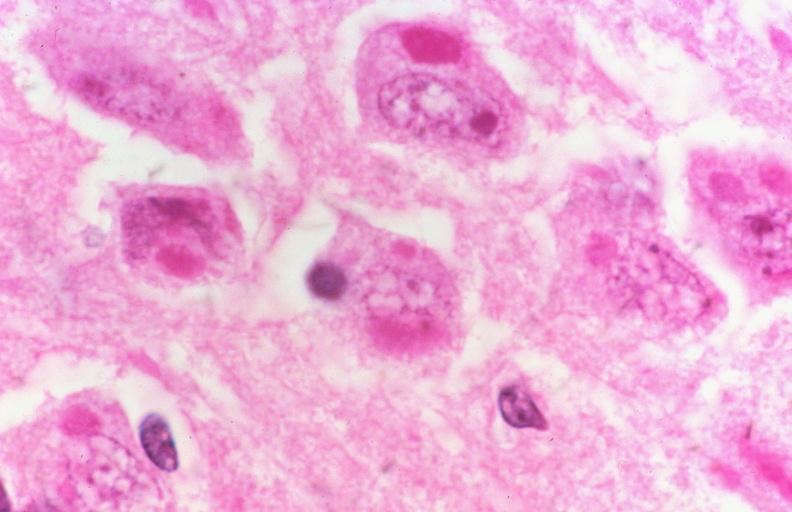what is present?
Answer the question using a single word or phrase. Nervous 